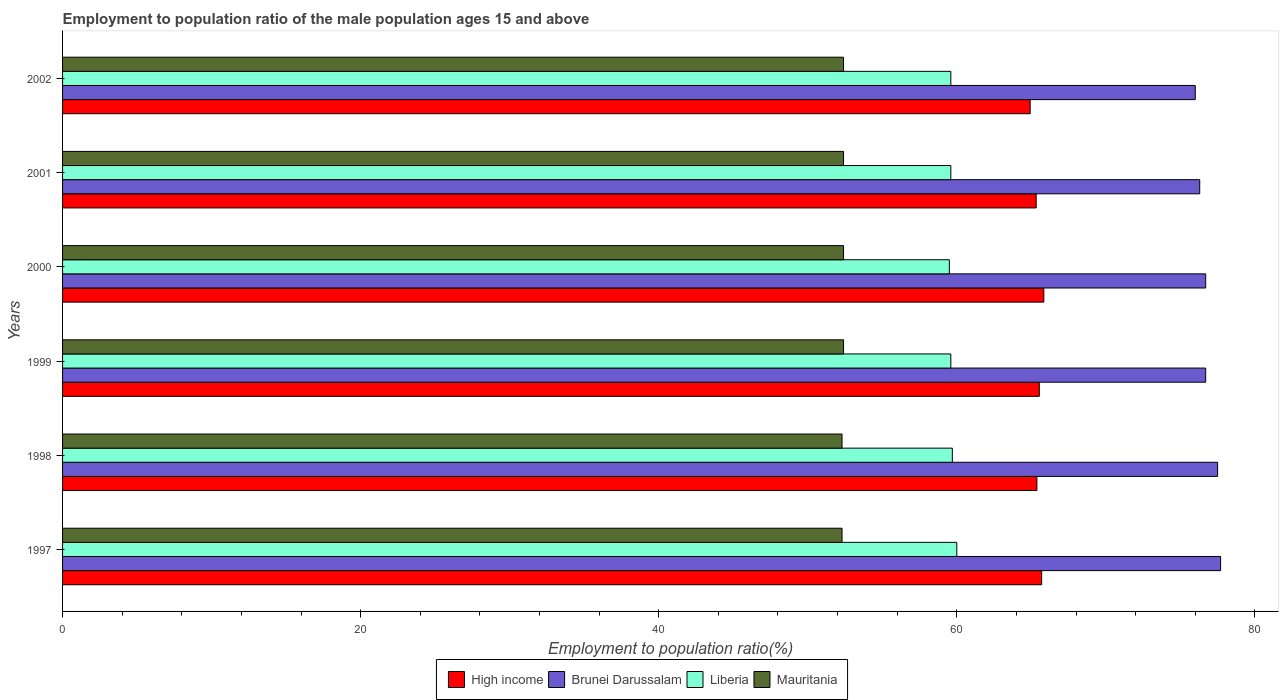How many different coloured bars are there?
Offer a terse response. 4. Are the number of bars on each tick of the Y-axis equal?
Provide a short and direct response. Yes. What is the employment to population ratio in Mauritania in 1999?
Your answer should be very brief. 52.4. Across all years, what is the maximum employment to population ratio in Liberia?
Offer a very short reply. 60. Across all years, what is the minimum employment to population ratio in Brunei Darussalam?
Ensure brevity in your answer.  76. In which year was the employment to population ratio in High income minimum?
Your answer should be compact. 2002. What is the total employment to population ratio in High income in the graph?
Give a very brief answer. 392.69. What is the difference between the employment to population ratio in Brunei Darussalam in 1999 and that in 2002?
Make the answer very short. 0.7. What is the difference between the employment to population ratio in High income in 2000 and the employment to population ratio in Mauritania in 1997?
Provide a succinct answer. 13.54. What is the average employment to population ratio in High income per year?
Provide a succinct answer. 65.45. In the year 1998, what is the difference between the employment to population ratio in High income and employment to population ratio in Liberia?
Provide a succinct answer. 5.67. In how many years, is the employment to population ratio in Liberia greater than 20 %?
Your answer should be compact. 6. What is the ratio of the employment to population ratio in High income in 1998 to that in 2002?
Give a very brief answer. 1.01. Is the employment to population ratio in Liberia in 1997 less than that in 2000?
Make the answer very short. No. Is the difference between the employment to population ratio in High income in 2001 and 2002 greater than the difference between the employment to population ratio in Liberia in 2001 and 2002?
Keep it short and to the point. Yes. What is the difference between the highest and the second highest employment to population ratio in Brunei Darussalam?
Ensure brevity in your answer.  0.2. What is the difference between the highest and the lowest employment to population ratio in High income?
Offer a very short reply. 0.92. Is it the case that in every year, the sum of the employment to population ratio in Mauritania and employment to population ratio in Liberia is greater than the sum of employment to population ratio in Brunei Darussalam and employment to population ratio in High income?
Give a very brief answer. No. What does the 2nd bar from the bottom in 1999 represents?
Provide a succinct answer. Brunei Darussalam. How many bars are there?
Make the answer very short. 24. What is the difference between two consecutive major ticks on the X-axis?
Make the answer very short. 20. Are the values on the major ticks of X-axis written in scientific E-notation?
Give a very brief answer. No. Does the graph contain any zero values?
Provide a succinct answer. No. Does the graph contain grids?
Provide a short and direct response. No. Where does the legend appear in the graph?
Keep it short and to the point. Bottom center. How many legend labels are there?
Keep it short and to the point. 4. What is the title of the graph?
Keep it short and to the point. Employment to population ratio of the male population ages 15 and above. Does "Guam" appear as one of the legend labels in the graph?
Your answer should be compact. No. What is the Employment to population ratio(%) of High income in 1997?
Give a very brief answer. 65.69. What is the Employment to population ratio(%) of Brunei Darussalam in 1997?
Provide a short and direct response. 77.7. What is the Employment to population ratio(%) of Mauritania in 1997?
Ensure brevity in your answer.  52.3. What is the Employment to population ratio(%) in High income in 1998?
Your answer should be very brief. 65.37. What is the Employment to population ratio(%) in Brunei Darussalam in 1998?
Ensure brevity in your answer.  77.5. What is the Employment to population ratio(%) in Liberia in 1998?
Provide a short and direct response. 59.7. What is the Employment to population ratio(%) of Mauritania in 1998?
Provide a short and direct response. 52.3. What is the Employment to population ratio(%) of High income in 1999?
Keep it short and to the point. 65.54. What is the Employment to population ratio(%) in Brunei Darussalam in 1999?
Provide a short and direct response. 76.7. What is the Employment to population ratio(%) in Liberia in 1999?
Provide a short and direct response. 59.6. What is the Employment to population ratio(%) in Mauritania in 1999?
Offer a very short reply. 52.4. What is the Employment to population ratio(%) in High income in 2000?
Your answer should be compact. 65.84. What is the Employment to population ratio(%) of Brunei Darussalam in 2000?
Provide a succinct answer. 76.7. What is the Employment to population ratio(%) of Liberia in 2000?
Provide a short and direct response. 59.5. What is the Employment to population ratio(%) in Mauritania in 2000?
Offer a terse response. 52.4. What is the Employment to population ratio(%) of High income in 2001?
Provide a succinct answer. 65.33. What is the Employment to population ratio(%) in Brunei Darussalam in 2001?
Make the answer very short. 76.3. What is the Employment to population ratio(%) in Liberia in 2001?
Make the answer very short. 59.6. What is the Employment to population ratio(%) in Mauritania in 2001?
Provide a short and direct response. 52.4. What is the Employment to population ratio(%) of High income in 2002?
Provide a short and direct response. 64.92. What is the Employment to population ratio(%) in Liberia in 2002?
Make the answer very short. 59.6. What is the Employment to population ratio(%) in Mauritania in 2002?
Make the answer very short. 52.4. Across all years, what is the maximum Employment to population ratio(%) in High income?
Keep it short and to the point. 65.84. Across all years, what is the maximum Employment to population ratio(%) in Brunei Darussalam?
Provide a short and direct response. 77.7. Across all years, what is the maximum Employment to population ratio(%) of Liberia?
Your response must be concise. 60. Across all years, what is the maximum Employment to population ratio(%) in Mauritania?
Give a very brief answer. 52.4. Across all years, what is the minimum Employment to population ratio(%) in High income?
Your answer should be very brief. 64.92. Across all years, what is the minimum Employment to population ratio(%) in Liberia?
Give a very brief answer. 59.5. Across all years, what is the minimum Employment to population ratio(%) in Mauritania?
Offer a very short reply. 52.3. What is the total Employment to population ratio(%) in High income in the graph?
Make the answer very short. 392.69. What is the total Employment to population ratio(%) in Brunei Darussalam in the graph?
Make the answer very short. 460.9. What is the total Employment to population ratio(%) in Liberia in the graph?
Offer a terse response. 358. What is the total Employment to population ratio(%) in Mauritania in the graph?
Provide a short and direct response. 314.2. What is the difference between the Employment to population ratio(%) of High income in 1997 and that in 1998?
Your answer should be compact. 0.32. What is the difference between the Employment to population ratio(%) in Liberia in 1997 and that in 1998?
Ensure brevity in your answer.  0.3. What is the difference between the Employment to population ratio(%) of Mauritania in 1997 and that in 1998?
Make the answer very short. 0. What is the difference between the Employment to population ratio(%) of High income in 1997 and that in 1999?
Offer a terse response. 0.16. What is the difference between the Employment to population ratio(%) in Liberia in 1997 and that in 1999?
Your answer should be very brief. 0.4. What is the difference between the Employment to population ratio(%) of Mauritania in 1997 and that in 1999?
Your answer should be very brief. -0.1. What is the difference between the Employment to population ratio(%) in High income in 1997 and that in 2000?
Make the answer very short. -0.15. What is the difference between the Employment to population ratio(%) of Mauritania in 1997 and that in 2000?
Make the answer very short. -0.1. What is the difference between the Employment to population ratio(%) of High income in 1997 and that in 2001?
Your response must be concise. 0.37. What is the difference between the Employment to population ratio(%) in Mauritania in 1997 and that in 2001?
Ensure brevity in your answer.  -0.1. What is the difference between the Employment to population ratio(%) of High income in 1997 and that in 2002?
Your answer should be very brief. 0.77. What is the difference between the Employment to population ratio(%) of Liberia in 1997 and that in 2002?
Give a very brief answer. 0.4. What is the difference between the Employment to population ratio(%) of Mauritania in 1997 and that in 2002?
Provide a short and direct response. -0.1. What is the difference between the Employment to population ratio(%) in High income in 1998 and that in 1999?
Provide a succinct answer. -0.16. What is the difference between the Employment to population ratio(%) in Liberia in 1998 and that in 1999?
Ensure brevity in your answer.  0.1. What is the difference between the Employment to population ratio(%) of High income in 1998 and that in 2000?
Offer a terse response. -0.47. What is the difference between the Employment to population ratio(%) in Brunei Darussalam in 1998 and that in 2000?
Make the answer very short. 0.8. What is the difference between the Employment to population ratio(%) of Liberia in 1998 and that in 2000?
Provide a short and direct response. 0.2. What is the difference between the Employment to population ratio(%) of High income in 1998 and that in 2001?
Offer a terse response. 0.05. What is the difference between the Employment to population ratio(%) in Brunei Darussalam in 1998 and that in 2001?
Offer a very short reply. 1.2. What is the difference between the Employment to population ratio(%) of Mauritania in 1998 and that in 2001?
Your answer should be very brief. -0.1. What is the difference between the Employment to population ratio(%) of High income in 1998 and that in 2002?
Give a very brief answer. 0.45. What is the difference between the Employment to population ratio(%) in Liberia in 1998 and that in 2002?
Offer a very short reply. 0.1. What is the difference between the Employment to population ratio(%) in High income in 1999 and that in 2000?
Your answer should be very brief. -0.3. What is the difference between the Employment to population ratio(%) in Brunei Darussalam in 1999 and that in 2000?
Your answer should be very brief. 0. What is the difference between the Employment to population ratio(%) in Liberia in 1999 and that in 2000?
Provide a succinct answer. 0.1. What is the difference between the Employment to population ratio(%) in High income in 1999 and that in 2001?
Your answer should be very brief. 0.21. What is the difference between the Employment to population ratio(%) in Brunei Darussalam in 1999 and that in 2001?
Your response must be concise. 0.4. What is the difference between the Employment to population ratio(%) of High income in 1999 and that in 2002?
Your answer should be compact. 0.61. What is the difference between the Employment to population ratio(%) in High income in 2000 and that in 2001?
Your answer should be compact. 0.51. What is the difference between the Employment to population ratio(%) of High income in 2000 and that in 2002?
Your answer should be compact. 0.92. What is the difference between the Employment to population ratio(%) of Brunei Darussalam in 2000 and that in 2002?
Your response must be concise. 0.7. What is the difference between the Employment to population ratio(%) of Liberia in 2000 and that in 2002?
Offer a very short reply. -0.1. What is the difference between the Employment to population ratio(%) in Mauritania in 2000 and that in 2002?
Provide a succinct answer. 0. What is the difference between the Employment to population ratio(%) in High income in 2001 and that in 2002?
Your answer should be compact. 0.4. What is the difference between the Employment to population ratio(%) of Liberia in 2001 and that in 2002?
Ensure brevity in your answer.  0. What is the difference between the Employment to population ratio(%) of Mauritania in 2001 and that in 2002?
Offer a terse response. 0. What is the difference between the Employment to population ratio(%) in High income in 1997 and the Employment to population ratio(%) in Brunei Darussalam in 1998?
Provide a short and direct response. -11.81. What is the difference between the Employment to population ratio(%) of High income in 1997 and the Employment to population ratio(%) of Liberia in 1998?
Your answer should be compact. 5.99. What is the difference between the Employment to population ratio(%) of High income in 1997 and the Employment to population ratio(%) of Mauritania in 1998?
Make the answer very short. 13.39. What is the difference between the Employment to population ratio(%) of Brunei Darussalam in 1997 and the Employment to population ratio(%) of Mauritania in 1998?
Your answer should be compact. 25.4. What is the difference between the Employment to population ratio(%) in Liberia in 1997 and the Employment to population ratio(%) in Mauritania in 1998?
Provide a short and direct response. 7.7. What is the difference between the Employment to population ratio(%) of High income in 1997 and the Employment to population ratio(%) of Brunei Darussalam in 1999?
Give a very brief answer. -11.01. What is the difference between the Employment to population ratio(%) in High income in 1997 and the Employment to population ratio(%) in Liberia in 1999?
Your response must be concise. 6.09. What is the difference between the Employment to population ratio(%) in High income in 1997 and the Employment to population ratio(%) in Mauritania in 1999?
Give a very brief answer. 13.29. What is the difference between the Employment to population ratio(%) in Brunei Darussalam in 1997 and the Employment to population ratio(%) in Liberia in 1999?
Your answer should be very brief. 18.1. What is the difference between the Employment to population ratio(%) of Brunei Darussalam in 1997 and the Employment to population ratio(%) of Mauritania in 1999?
Make the answer very short. 25.3. What is the difference between the Employment to population ratio(%) in Liberia in 1997 and the Employment to population ratio(%) in Mauritania in 1999?
Ensure brevity in your answer.  7.6. What is the difference between the Employment to population ratio(%) in High income in 1997 and the Employment to population ratio(%) in Brunei Darussalam in 2000?
Offer a terse response. -11.01. What is the difference between the Employment to population ratio(%) in High income in 1997 and the Employment to population ratio(%) in Liberia in 2000?
Offer a terse response. 6.19. What is the difference between the Employment to population ratio(%) of High income in 1997 and the Employment to population ratio(%) of Mauritania in 2000?
Keep it short and to the point. 13.29. What is the difference between the Employment to population ratio(%) in Brunei Darussalam in 1997 and the Employment to population ratio(%) in Liberia in 2000?
Offer a very short reply. 18.2. What is the difference between the Employment to population ratio(%) in Brunei Darussalam in 1997 and the Employment to population ratio(%) in Mauritania in 2000?
Ensure brevity in your answer.  25.3. What is the difference between the Employment to population ratio(%) of High income in 1997 and the Employment to population ratio(%) of Brunei Darussalam in 2001?
Your answer should be compact. -10.61. What is the difference between the Employment to population ratio(%) of High income in 1997 and the Employment to population ratio(%) of Liberia in 2001?
Provide a succinct answer. 6.09. What is the difference between the Employment to population ratio(%) of High income in 1997 and the Employment to population ratio(%) of Mauritania in 2001?
Provide a short and direct response. 13.29. What is the difference between the Employment to population ratio(%) of Brunei Darussalam in 1997 and the Employment to population ratio(%) of Mauritania in 2001?
Offer a terse response. 25.3. What is the difference between the Employment to population ratio(%) in Liberia in 1997 and the Employment to population ratio(%) in Mauritania in 2001?
Your answer should be very brief. 7.6. What is the difference between the Employment to population ratio(%) of High income in 1997 and the Employment to population ratio(%) of Brunei Darussalam in 2002?
Your answer should be compact. -10.31. What is the difference between the Employment to population ratio(%) of High income in 1997 and the Employment to population ratio(%) of Liberia in 2002?
Provide a succinct answer. 6.09. What is the difference between the Employment to population ratio(%) in High income in 1997 and the Employment to population ratio(%) in Mauritania in 2002?
Your response must be concise. 13.29. What is the difference between the Employment to population ratio(%) of Brunei Darussalam in 1997 and the Employment to population ratio(%) of Liberia in 2002?
Make the answer very short. 18.1. What is the difference between the Employment to population ratio(%) in Brunei Darussalam in 1997 and the Employment to population ratio(%) in Mauritania in 2002?
Offer a terse response. 25.3. What is the difference between the Employment to population ratio(%) of Liberia in 1997 and the Employment to population ratio(%) of Mauritania in 2002?
Ensure brevity in your answer.  7.6. What is the difference between the Employment to population ratio(%) in High income in 1998 and the Employment to population ratio(%) in Brunei Darussalam in 1999?
Offer a terse response. -11.33. What is the difference between the Employment to population ratio(%) of High income in 1998 and the Employment to population ratio(%) of Liberia in 1999?
Keep it short and to the point. 5.77. What is the difference between the Employment to population ratio(%) of High income in 1998 and the Employment to population ratio(%) of Mauritania in 1999?
Give a very brief answer. 12.97. What is the difference between the Employment to population ratio(%) in Brunei Darussalam in 1998 and the Employment to population ratio(%) in Mauritania in 1999?
Give a very brief answer. 25.1. What is the difference between the Employment to population ratio(%) in Liberia in 1998 and the Employment to population ratio(%) in Mauritania in 1999?
Make the answer very short. 7.3. What is the difference between the Employment to population ratio(%) in High income in 1998 and the Employment to population ratio(%) in Brunei Darussalam in 2000?
Your response must be concise. -11.33. What is the difference between the Employment to population ratio(%) in High income in 1998 and the Employment to population ratio(%) in Liberia in 2000?
Give a very brief answer. 5.87. What is the difference between the Employment to population ratio(%) in High income in 1998 and the Employment to population ratio(%) in Mauritania in 2000?
Your answer should be very brief. 12.97. What is the difference between the Employment to population ratio(%) in Brunei Darussalam in 1998 and the Employment to population ratio(%) in Mauritania in 2000?
Your response must be concise. 25.1. What is the difference between the Employment to population ratio(%) of Liberia in 1998 and the Employment to population ratio(%) of Mauritania in 2000?
Give a very brief answer. 7.3. What is the difference between the Employment to population ratio(%) in High income in 1998 and the Employment to population ratio(%) in Brunei Darussalam in 2001?
Ensure brevity in your answer.  -10.93. What is the difference between the Employment to population ratio(%) in High income in 1998 and the Employment to population ratio(%) in Liberia in 2001?
Offer a terse response. 5.77. What is the difference between the Employment to population ratio(%) of High income in 1998 and the Employment to population ratio(%) of Mauritania in 2001?
Give a very brief answer. 12.97. What is the difference between the Employment to population ratio(%) of Brunei Darussalam in 1998 and the Employment to population ratio(%) of Liberia in 2001?
Make the answer very short. 17.9. What is the difference between the Employment to population ratio(%) in Brunei Darussalam in 1998 and the Employment to population ratio(%) in Mauritania in 2001?
Your answer should be very brief. 25.1. What is the difference between the Employment to population ratio(%) of High income in 1998 and the Employment to population ratio(%) of Brunei Darussalam in 2002?
Give a very brief answer. -10.63. What is the difference between the Employment to population ratio(%) of High income in 1998 and the Employment to population ratio(%) of Liberia in 2002?
Offer a terse response. 5.77. What is the difference between the Employment to population ratio(%) in High income in 1998 and the Employment to population ratio(%) in Mauritania in 2002?
Ensure brevity in your answer.  12.97. What is the difference between the Employment to population ratio(%) in Brunei Darussalam in 1998 and the Employment to population ratio(%) in Mauritania in 2002?
Provide a succinct answer. 25.1. What is the difference between the Employment to population ratio(%) in Liberia in 1998 and the Employment to population ratio(%) in Mauritania in 2002?
Ensure brevity in your answer.  7.3. What is the difference between the Employment to population ratio(%) of High income in 1999 and the Employment to population ratio(%) of Brunei Darussalam in 2000?
Make the answer very short. -11.16. What is the difference between the Employment to population ratio(%) of High income in 1999 and the Employment to population ratio(%) of Liberia in 2000?
Provide a succinct answer. 6.04. What is the difference between the Employment to population ratio(%) in High income in 1999 and the Employment to population ratio(%) in Mauritania in 2000?
Provide a succinct answer. 13.14. What is the difference between the Employment to population ratio(%) of Brunei Darussalam in 1999 and the Employment to population ratio(%) of Liberia in 2000?
Make the answer very short. 17.2. What is the difference between the Employment to population ratio(%) of Brunei Darussalam in 1999 and the Employment to population ratio(%) of Mauritania in 2000?
Your answer should be very brief. 24.3. What is the difference between the Employment to population ratio(%) of High income in 1999 and the Employment to population ratio(%) of Brunei Darussalam in 2001?
Your answer should be compact. -10.76. What is the difference between the Employment to population ratio(%) of High income in 1999 and the Employment to population ratio(%) of Liberia in 2001?
Provide a succinct answer. 5.94. What is the difference between the Employment to population ratio(%) in High income in 1999 and the Employment to population ratio(%) in Mauritania in 2001?
Offer a terse response. 13.14. What is the difference between the Employment to population ratio(%) of Brunei Darussalam in 1999 and the Employment to population ratio(%) of Liberia in 2001?
Keep it short and to the point. 17.1. What is the difference between the Employment to population ratio(%) in Brunei Darussalam in 1999 and the Employment to population ratio(%) in Mauritania in 2001?
Offer a very short reply. 24.3. What is the difference between the Employment to population ratio(%) of High income in 1999 and the Employment to population ratio(%) of Brunei Darussalam in 2002?
Give a very brief answer. -10.46. What is the difference between the Employment to population ratio(%) of High income in 1999 and the Employment to population ratio(%) of Liberia in 2002?
Your answer should be compact. 5.94. What is the difference between the Employment to population ratio(%) in High income in 1999 and the Employment to population ratio(%) in Mauritania in 2002?
Keep it short and to the point. 13.14. What is the difference between the Employment to population ratio(%) in Brunei Darussalam in 1999 and the Employment to population ratio(%) in Mauritania in 2002?
Your answer should be very brief. 24.3. What is the difference between the Employment to population ratio(%) of High income in 2000 and the Employment to population ratio(%) of Brunei Darussalam in 2001?
Provide a succinct answer. -10.46. What is the difference between the Employment to population ratio(%) of High income in 2000 and the Employment to population ratio(%) of Liberia in 2001?
Keep it short and to the point. 6.24. What is the difference between the Employment to population ratio(%) of High income in 2000 and the Employment to population ratio(%) of Mauritania in 2001?
Ensure brevity in your answer.  13.44. What is the difference between the Employment to population ratio(%) in Brunei Darussalam in 2000 and the Employment to population ratio(%) in Liberia in 2001?
Give a very brief answer. 17.1. What is the difference between the Employment to population ratio(%) of Brunei Darussalam in 2000 and the Employment to population ratio(%) of Mauritania in 2001?
Give a very brief answer. 24.3. What is the difference between the Employment to population ratio(%) of Liberia in 2000 and the Employment to population ratio(%) of Mauritania in 2001?
Your response must be concise. 7.1. What is the difference between the Employment to population ratio(%) of High income in 2000 and the Employment to population ratio(%) of Brunei Darussalam in 2002?
Your response must be concise. -10.16. What is the difference between the Employment to population ratio(%) of High income in 2000 and the Employment to population ratio(%) of Liberia in 2002?
Keep it short and to the point. 6.24. What is the difference between the Employment to population ratio(%) in High income in 2000 and the Employment to population ratio(%) in Mauritania in 2002?
Make the answer very short. 13.44. What is the difference between the Employment to population ratio(%) in Brunei Darussalam in 2000 and the Employment to population ratio(%) in Liberia in 2002?
Keep it short and to the point. 17.1. What is the difference between the Employment to population ratio(%) in Brunei Darussalam in 2000 and the Employment to population ratio(%) in Mauritania in 2002?
Your answer should be compact. 24.3. What is the difference between the Employment to population ratio(%) in High income in 2001 and the Employment to population ratio(%) in Brunei Darussalam in 2002?
Your answer should be compact. -10.67. What is the difference between the Employment to population ratio(%) in High income in 2001 and the Employment to population ratio(%) in Liberia in 2002?
Provide a short and direct response. 5.73. What is the difference between the Employment to population ratio(%) in High income in 2001 and the Employment to population ratio(%) in Mauritania in 2002?
Your response must be concise. 12.93. What is the difference between the Employment to population ratio(%) of Brunei Darussalam in 2001 and the Employment to population ratio(%) of Liberia in 2002?
Provide a short and direct response. 16.7. What is the difference between the Employment to population ratio(%) in Brunei Darussalam in 2001 and the Employment to population ratio(%) in Mauritania in 2002?
Your answer should be compact. 23.9. What is the average Employment to population ratio(%) of High income per year?
Your answer should be very brief. 65.45. What is the average Employment to population ratio(%) in Brunei Darussalam per year?
Your answer should be compact. 76.82. What is the average Employment to population ratio(%) of Liberia per year?
Give a very brief answer. 59.67. What is the average Employment to population ratio(%) in Mauritania per year?
Your response must be concise. 52.37. In the year 1997, what is the difference between the Employment to population ratio(%) in High income and Employment to population ratio(%) in Brunei Darussalam?
Your answer should be very brief. -12.01. In the year 1997, what is the difference between the Employment to population ratio(%) of High income and Employment to population ratio(%) of Liberia?
Give a very brief answer. 5.69. In the year 1997, what is the difference between the Employment to population ratio(%) of High income and Employment to population ratio(%) of Mauritania?
Provide a succinct answer. 13.39. In the year 1997, what is the difference between the Employment to population ratio(%) of Brunei Darussalam and Employment to population ratio(%) of Liberia?
Your response must be concise. 17.7. In the year 1997, what is the difference between the Employment to population ratio(%) in Brunei Darussalam and Employment to population ratio(%) in Mauritania?
Make the answer very short. 25.4. In the year 1998, what is the difference between the Employment to population ratio(%) of High income and Employment to population ratio(%) of Brunei Darussalam?
Your answer should be very brief. -12.13. In the year 1998, what is the difference between the Employment to population ratio(%) in High income and Employment to population ratio(%) in Liberia?
Make the answer very short. 5.67. In the year 1998, what is the difference between the Employment to population ratio(%) in High income and Employment to population ratio(%) in Mauritania?
Offer a very short reply. 13.07. In the year 1998, what is the difference between the Employment to population ratio(%) in Brunei Darussalam and Employment to population ratio(%) in Liberia?
Ensure brevity in your answer.  17.8. In the year 1998, what is the difference between the Employment to population ratio(%) in Brunei Darussalam and Employment to population ratio(%) in Mauritania?
Your answer should be very brief. 25.2. In the year 1999, what is the difference between the Employment to population ratio(%) of High income and Employment to population ratio(%) of Brunei Darussalam?
Your answer should be compact. -11.16. In the year 1999, what is the difference between the Employment to population ratio(%) in High income and Employment to population ratio(%) in Liberia?
Provide a succinct answer. 5.94. In the year 1999, what is the difference between the Employment to population ratio(%) of High income and Employment to population ratio(%) of Mauritania?
Keep it short and to the point. 13.14. In the year 1999, what is the difference between the Employment to population ratio(%) of Brunei Darussalam and Employment to population ratio(%) of Liberia?
Your answer should be compact. 17.1. In the year 1999, what is the difference between the Employment to population ratio(%) in Brunei Darussalam and Employment to population ratio(%) in Mauritania?
Provide a succinct answer. 24.3. In the year 1999, what is the difference between the Employment to population ratio(%) in Liberia and Employment to population ratio(%) in Mauritania?
Offer a very short reply. 7.2. In the year 2000, what is the difference between the Employment to population ratio(%) of High income and Employment to population ratio(%) of Brunei Darussalam?
Offer a terse response. -10.86. In the year 2000, what is the difference between the Employment to population ratio(%) in High income and Employment to population ratio(%) in Liberia?
Keep it short and to the point. 6.34. In the year 2000, what is the difference between the Employment to population ratio(%) in High income and Employment to population ratio(%) in Mauritania?
Make the answer very short. 13.44. In the year 2000, what is the difference between the Employment to population ratio(%) in Brunei Darussalam and Employment to population ratio(%) in Liberia?
Your response must be concise. 17.2. In the year 2000, what is the difference between the Employment to population ratio(%) in Brunei Darussalam and Employment to population ratio(%) in Mauritania?
Your answer should be compact. 24.3. In the year 2001, what is the difference between the Employment to population ratio(%) in High income and Employment to population ratio(%) in Brunei Darussalam?
Your answer should be compact. -10.97. In the year 2001, what is the difference between the Employment to population ratio(%) in High income and Employment to population ratio(%) in Liberia?
Ensure brevity in your answer.  5.73. In the year 2001, what is the difference between the Employment to population ratio(%) in High income and Employment to population ratio(%) in Mauritania?
Provide a short and direct response. 12.93. In the year 2001, what is the difference between the Employment to population ratio(%) of Brunei Darussalam and Employment to population ratio(%) of Mauritania?
Provide a short and direct response. 23.9. In the year 2001, what is the difference between the Employment to population ratio(%) in Liberia and Employment to population ratio(%) in Mauritania?
Make the answer very short. 7.2. In the year 2002, what is the difference between the Employment to population ratio(%) in High income and Employment to population ratio(%) in Brunei Darussalam?
Provide a short and direct response. -11.08. In the year 2002, what is the difference between the Employment to population ratio(%) in High income and Employment to population ratio(%) in Liberia?
Offer a terse response. 5.32. In the year 2002, what is the difference between the Employment to population ratio(%) of High income and Employment to population ratio(%) of Mauritania?
Provide a succinct answer. 12.52. In the year 2002, what is the difference between the Employment to population ratio(%) in Brunei Darussalam and Employment to population ratio(%) in Mauritania?
Ensure brevity in your answer.  23.6. What is the ratio of the Employment to population ratio(%) in High income in 1997 to that in 1998?
Offer a very short reply. 1. What is the ratio of the Employment to population ratio(%) in Liberia in 1997 to that in 1998?
Make the answer very short. 1. What is the ratio of the Employment to population ratio(%) of Mauritania in 1997 to that in 1998?
Your response must be concise. 1. What is the ratio of the Employment to population ratio(%) of Liberia in 1997 to that in 1999?
Your answer should be very brief. 1.01. What is the ratio of the Employment to population ratio(%) in Brunei Darussalam in 1997 to that in 2000?
Your response must be concise. 1.01. What is the ratio of the Employment to population ratio(%) of Liberia in 1997 to that in 2000?
Offer a terse response. 1.01. What is the ratio of the Employment to population ratio(%) of Mauritania in 1997 to that in 2000?
Your answer should be compact. 1. What is the ratio of the Employment to population ratio(%) in High income in 1997 to that in 2001?
Your response must be concise. 1.01. What is the ratio of the Employment to population ratio(%) in Brunei Darussalam in 1997 to that in 2001?
Ensure brevity in your answer.  1.02. What is the ratio of the Employment to population ratio(%) of Mauritania in 1997 to that in 2001?
Your response must be concise. 1. What is the ratio of the Employment to population ratio(%) in High income in 1997 to that in 2002?
Keep it short and to the point. 1.01. What is the ratio of the Employment to population ratio(%) of Brunei Darussalam in 1997 to that in 2002?
Give a very brief answer. 1.02. What is the ratio of the Employment to population ratio(%) in Liberia in 1997 to that in 2002?
Your answer should be very brief. 1.01. What is the ratio of the Employment to population ratio(%) in Brunei Darussalam in 1998 to that in 1999?
Your response must be concise. 1.01. What is the ratio of the Employment to population ratio(%) in Liberia in 1998 to that in 1999?
Ensure brevity in your answer.  1. What is the ratio of the Employment to population ratio(%) in High income in 1998 to that in 2000?
Offer a terse response. 0.99. What is the ratio of the Employment to population ratio(%) in Brunei Darussalam in 1998 to that in 2000?
Your response must be concise. 1.01. What is the ratio of the Employment to population ratio(%) in Liberia in 1998 to that in 2000?
Offer a very short reply. 1. What is the ratio of the Employment to population ratio(%) in Brunei Darussalam in 1998 to that in 2001?
Provide a succinct answer. 1.02. What is the ratio of the Employment to population ratio(%) of Brunei Darussalam in 1998 to that in 2002?
Provide a succinct answer. 1.02. What is the ratio of the Employment to population ratio(%) in Mauritania in 1998 to that in 2002?
Provide a succinct answer. 1. What is the ratio of the Employment to population ratio(%) of High income in 1999 to that in 2000?
Give a very brief answer. 1. What is the ratio of the Employment to population ratio(%) of Liberia in 1999 to that in 2000?
Your response must be concise. 1. What is the ratio of the Employment to population ratio(%) of Brunei Darussalam in 1999 to that in 2001?
Your answer should be very brief. 1.01. What is the ratio of the Employment to population ratio(%) in Mauritania in 1999 to that in 2001?
Make the answer very short. 1. What is the ratio of the Employment to population ratio(%) in High income in 1999 to that in 2002?
Offer a terse response. 1.01. What is the ratio of the Employment to population ratio(%) of Brunei Darussalam in 1999 to that in 2002?
Your answer should be compact. 1.01. What is the ratio of the Employment to population ratio(%) in Liberia in 1999 to that in 2002?
Your answer should be very brief. 1. What is the ratio of the Employment to population ratio(%) in High income in 2000 to that in 2001?
Provide a short and direct response. 1.01. What is the ratio of the Employment to population ratio(%) of Mauritania in 2000 to that in 2001?
Offer a terse response. 1. What is the ratio of the Employment to population ratio(%) in High income in 2000 to that in 2002?
Your response must be concise. 1.01. What is the ratio of the Employment to population ratio(%) of Brunei Darussalam in 2000 to that in 2002?
Offer a very short reply. 1.01. What is the ratio of the Employment to population ratio(%) in Liberia in 2000 to that in 2002?
Your answer should be compact. 1. What is the ratio of the Employment to population ratio(%) in Brunei Darussalam in 2001 to that in 2002?
Offer a very short reply. 1. What is the ratio of the Employment to population ratio(%) of Liberia in 2001 to that in 2002?
Your answer should be very brief. 1. What is the difference between the highest and the second highest Employment to population ratio(%) in High income?
Your answer should be very brief. 0.15. What is the difference between the highest and the second highest Employment to population ratio(%) of Brunei Darussalam?
Keep it short and to the point. 0.2. What is the difference between the highest and the second highest Employment to population ratio(%) of Mauritania?
Provide a succinct answer. 0. What is the difference between the highest and the lowest Employment to population ratio(%) of High income?
Your answer should be very brief. 0.92. What is the difference between the highest and the lowest Employment to population ratio(%) of Liberia?
Make the answer very short. 0.5. 